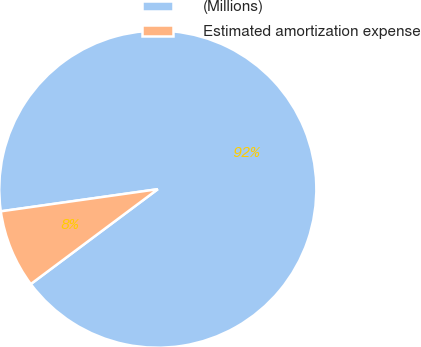<chart> <loc_0><loc_0><loc_500><loc_500><pie_chart><fcel>(Millions)<fcel>Estimated amortization expense<nl><fcel>92.02%<fcel>7.98%<nl></chart> 